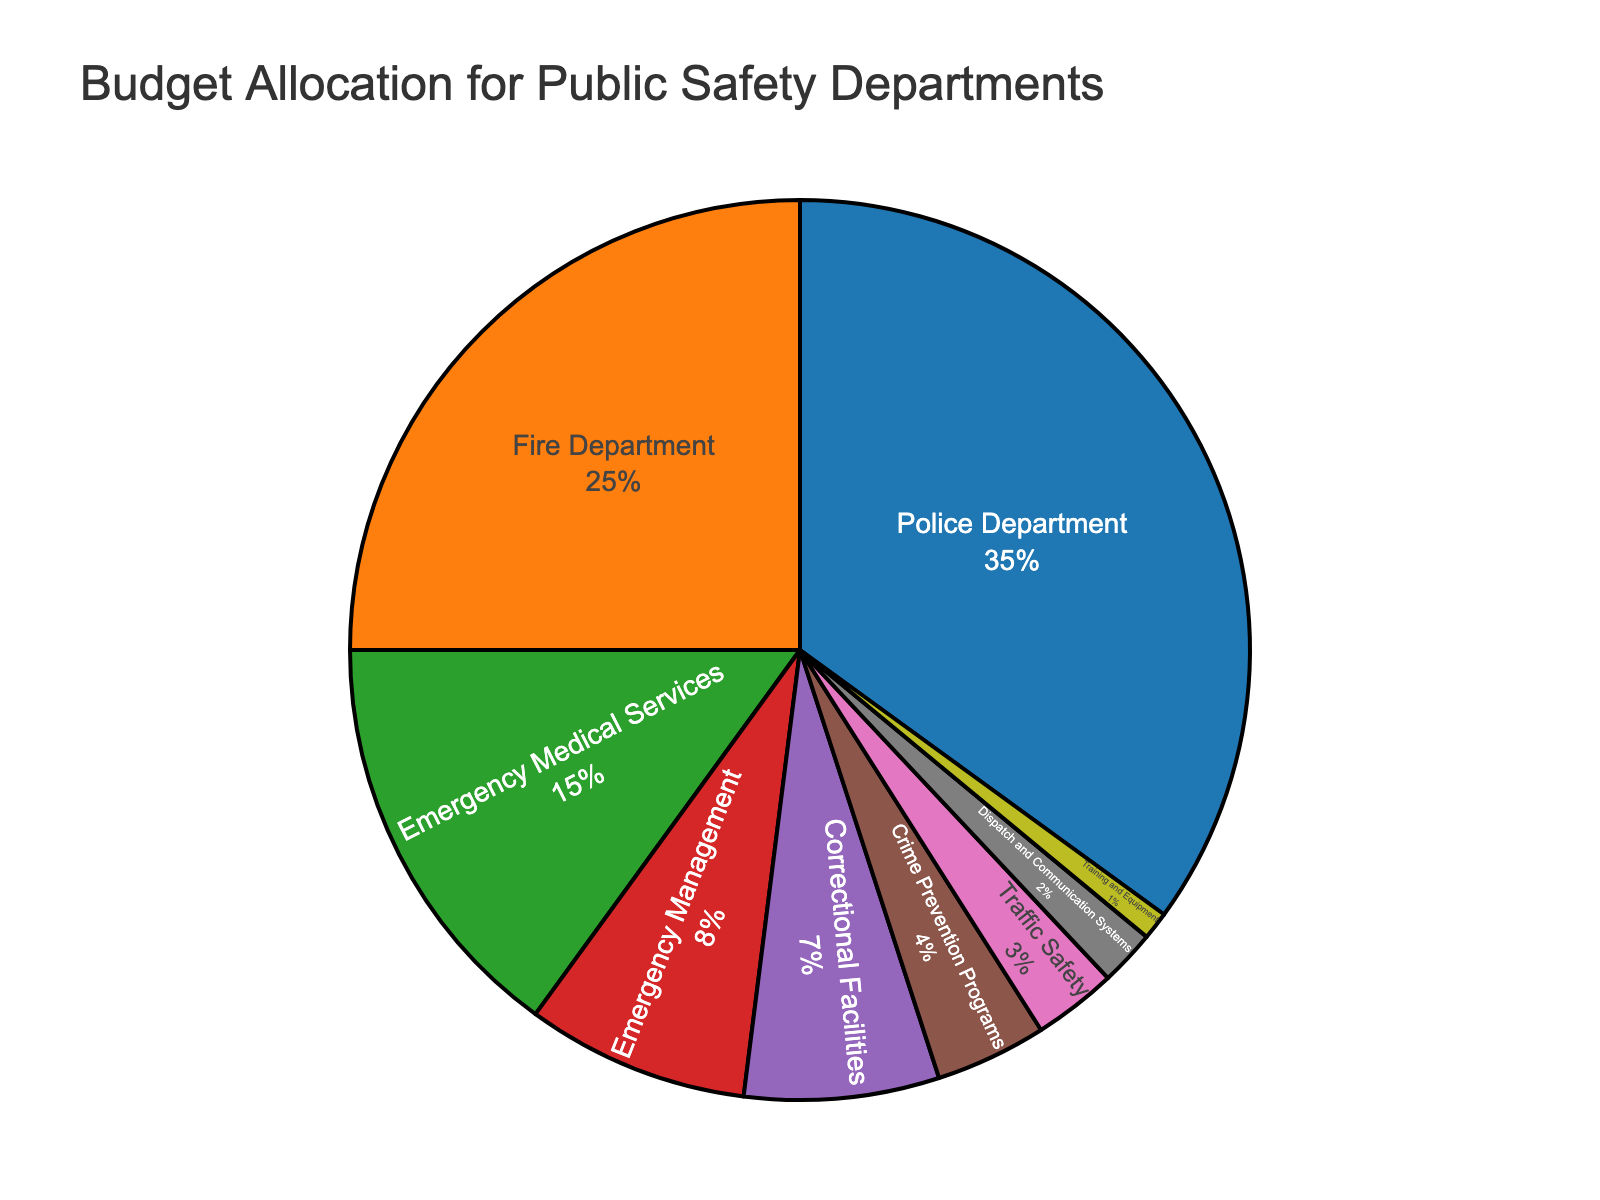What percentage of the budget is allocated to the Police Department? The Police Department slice on the pie chart is labeled with 35%.
Answer: 35% Which department receives the smallest portion of the budget? The slice for Training and Equipment is the smallest and labeled with 1%.
Answer: Training and Equipment How much more of the budget is allocated to Fire Department compared to Crime Prevention Programs? The Fire Department has 25% of the budget, and Crime Prevention Programs have 4%. The difference is 25% - 4%.
Answer: 21% What is the combined budget percentage for Emergency Medical Services and Correctional Facilities? Adding the percentages for Emergency Medical Services (15%) and Correctional Facilities (7%) gives 15% + 7%.
Answer: 22% Which department receives the second-largest budget allocation? The slice for the Fire Department is the second largest, labeled with 25%.
Answer: Fire Department Is the budget for Emergency Management greater than the budget for Traffic Safety? Emergency Management is allocated 8%, while Traffic Safety has 3%. 8% is greater than 3%.
Answer: Yes What is the sum of the budgets for all departments focused on emergency response (Police, Fire, EMS, Emergency Management)? Sum the percentages for Police Department (35%), Fire Department (25%), Emergency Medical Services (15%), and Emergency Management (8%). 35% + 25% + 15% + 8%.
Answer: 83% Compare the budget allocation between Crime Prevention Programs and Dispatch and Communication Systems. Crime Prevention Programs have 4%, and Dispatch and Communication Systems have 2%. 4% is greater than 2%.
Answer: Crime Prevention Programs What percentage of the budget is allocated to all departments not directly involved in law enforcement (i.e., excluding Police Department)? Subtract the Police Department's percentage (35%) from 100%. 100% - 35%.
Answer: 65% Which category has a budget allocation closest to 10%? Emergency Management is closest to 10%, with a budget of 8%.
Answer: Emergency Management 